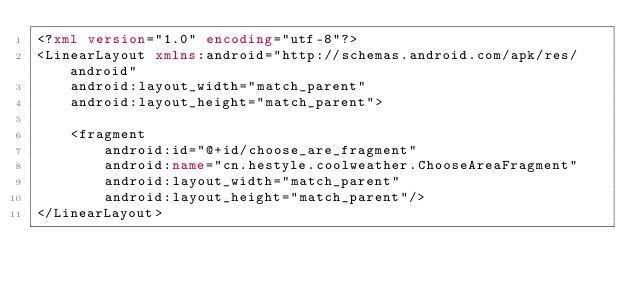Convert code to text. <code><loc_0><loc_0><loc_500><loc_500><_XML_><?xml version="1.0" encoding="utf-8"?>
<LinearLayout xmlns:android="http://schemas.android.com/apk/res/android"
    android:layout_width="match_parent"
    android:layout_height="match_parent">

    <fragment
        android:id="@+id/choose_are_fragment"
        android:name="cn.hestyle.coolweather.ChooseAreaFragment"
        android:layout_width="match_parent"
        android:layout_height="match_parent"/>
</LinearLayout></code> 